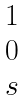<formula> <loc_0><loc_0><loc_500><loc_500>\begin{matrix} 1 \\ 0 \\ s \end{matrix}</formula> 